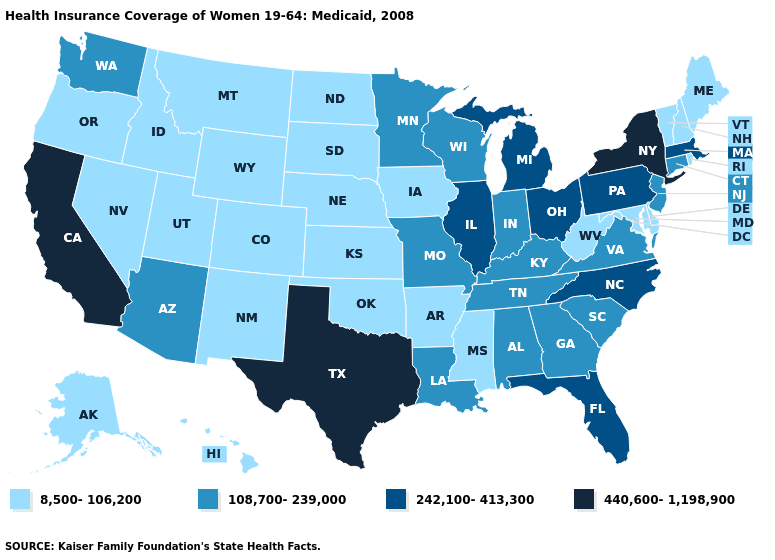Name the states that have a value in the range 8,500-106,200?
Keep it brief. Alaska, Arkansas, Colorado, Delaware, Hawaii, Idaho, Iowa, Kansas, Maine, Maryland, Mississippi, Montana, Nebraska, Nevada, New Hampshire, New Mexico, North Dakota, Oklahoma, Oregon, Rhode Island, South Dakota, Utah, Vermont, West Virginia, Wyoming. Does Utah have a lower value than Montana?
Concise answer only. No. Does the first symbol in the legend represent the smallest category?
Give a very brief answer. Yes. Does North Carolina have a lower value than New York?
Keep it brief. Yes. Which states have the highest value in the USA?
Be succinct. California, New York, Texas. Is the legend a continuous bar?
Be succinct. No. Name the states that have a value in the range 8,500-106,200?
Write a very short answer. Alaska, Arkansas, Colorado, Delaware, Hawaii, Idaho, Iowa, Kansas, Maine, Maryland, Mississippi, Montana, Nebraska, Nevada, New Hampshire, New Mexico, North Dakota, Oklahoma, Oregon, Rhode Island, South Dakota, Utah, Vermont, West Virginia, Wyoming. Name the states that have a value in the range 440,600-1,198,900?
Answer briefly. California, New York, Texas. Name the states that have a value in the range 440,600-1,198,900?
Give a very brief answer. California, New York, Texas. Name the states that have a value in the range 440,600-1,198,900?
Give a very brief answer. California, New York, Texas. What is the value of Kentucky?
Write a very short answer. 108,700-239,000. Among the states that border Alabama , does Florida have the highest value?
Be succinct. Yes. Does the map have missing data?
Give a very brief answer. No. How many symbols are there in the legend?
Concise answer only. 4. What is the value of Nevada?
Quick response, please. 8,500-106,200. 